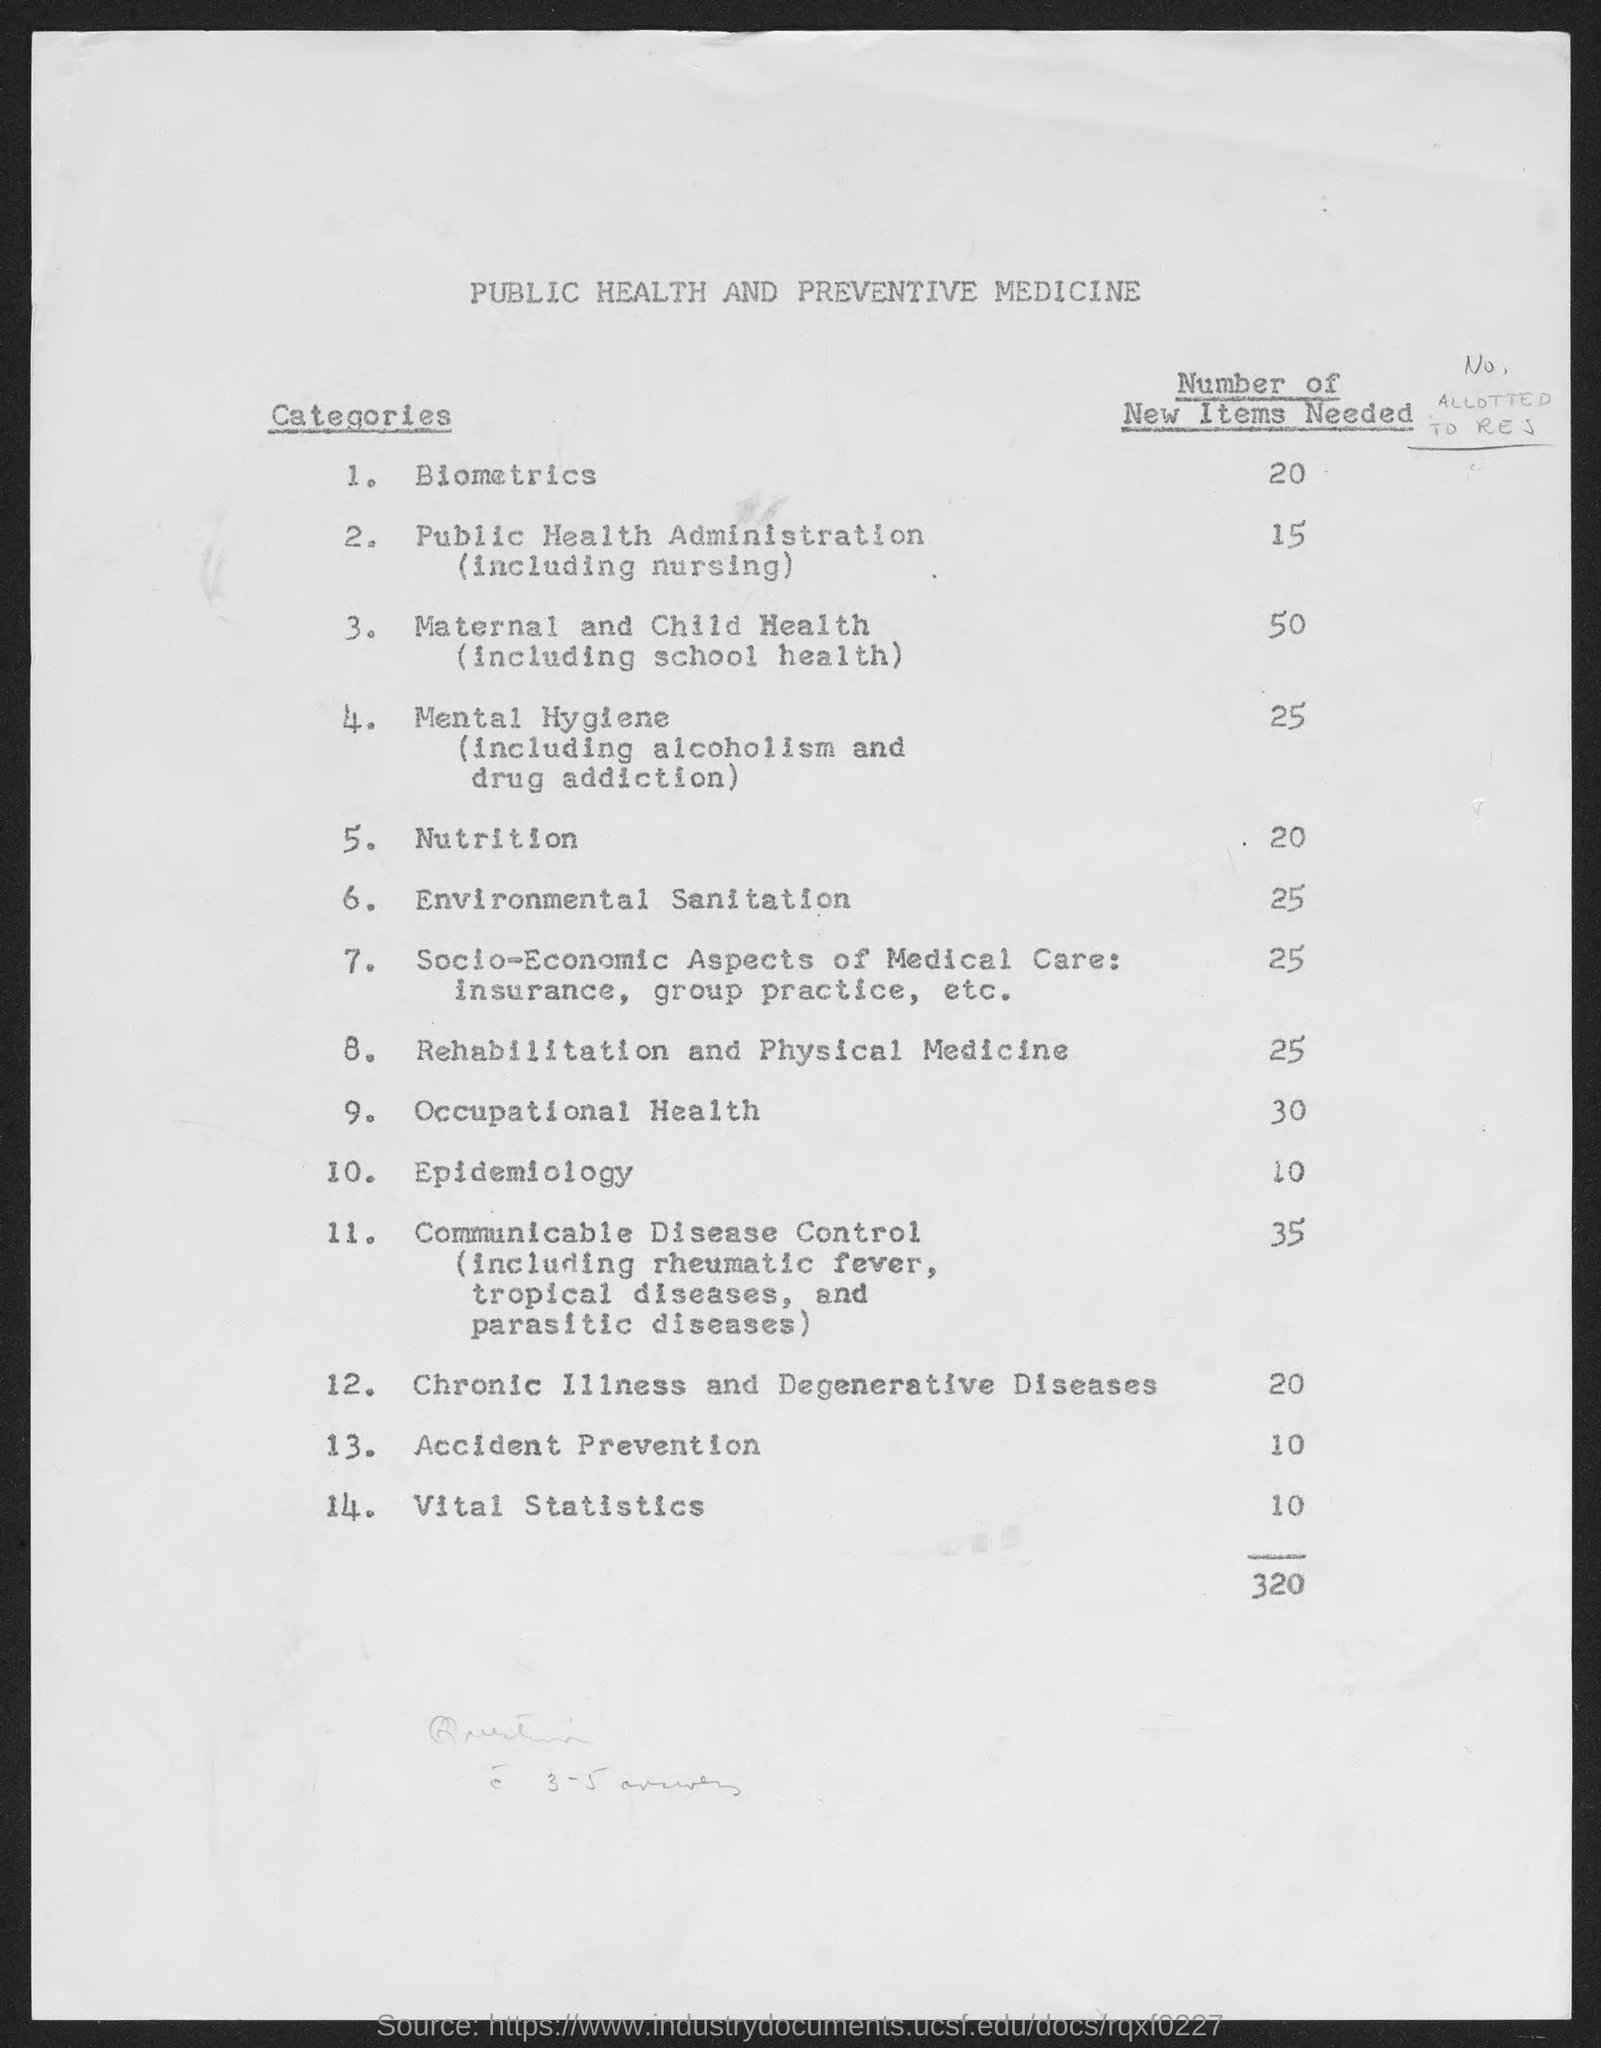What is the document title?
Provide a short and direct response. PUBLIC HEALTH AND PREVENTIVE MEDICINE. How many new items are needed in Biometrics?
Provide a short and direct response. 20. What is the total number of new items needed?
Provide a succinct answer. 320. What is the 14th Category?
Your answer should be very brief. VITAL STATISTICS. 